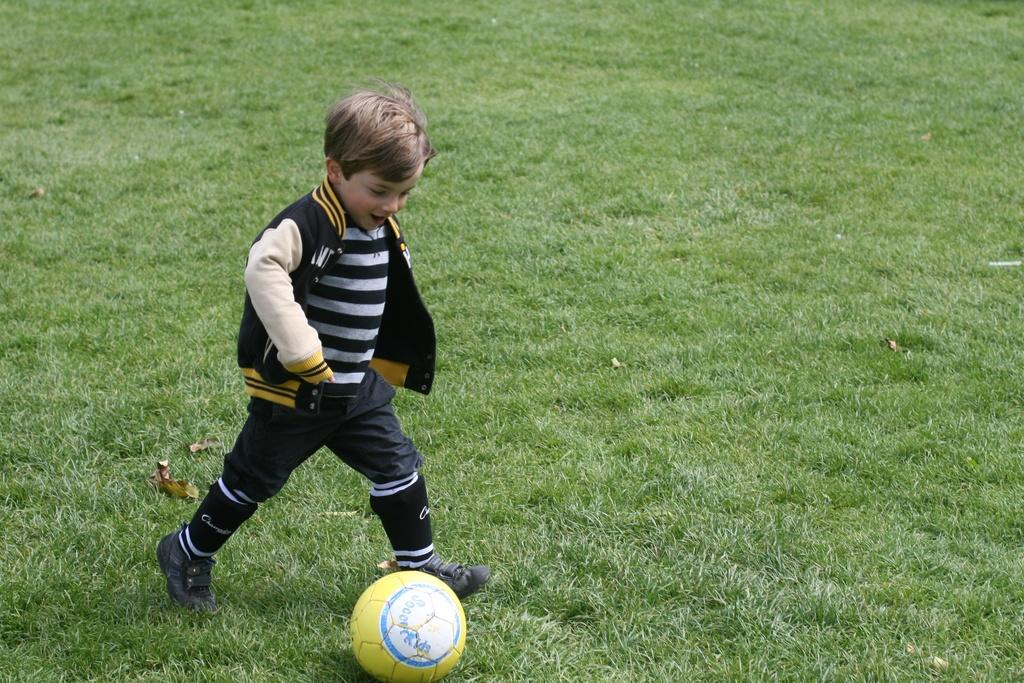What is the main subject of the image? The main subject of the image is a kid. What is the kid wearing in the image? The kid is wearing a black dress in the image. What is the kid holding or carrying in the image? The kid is walking with a football in the image. What type of environment is visible in the image? The grassland is visible in the image. How much money is the kid holding in the image? There is no money visible in the image; the kid is holding a football. What type of book is the kid reading in the image? There is no book present in the image; the kid is walking with a football. 